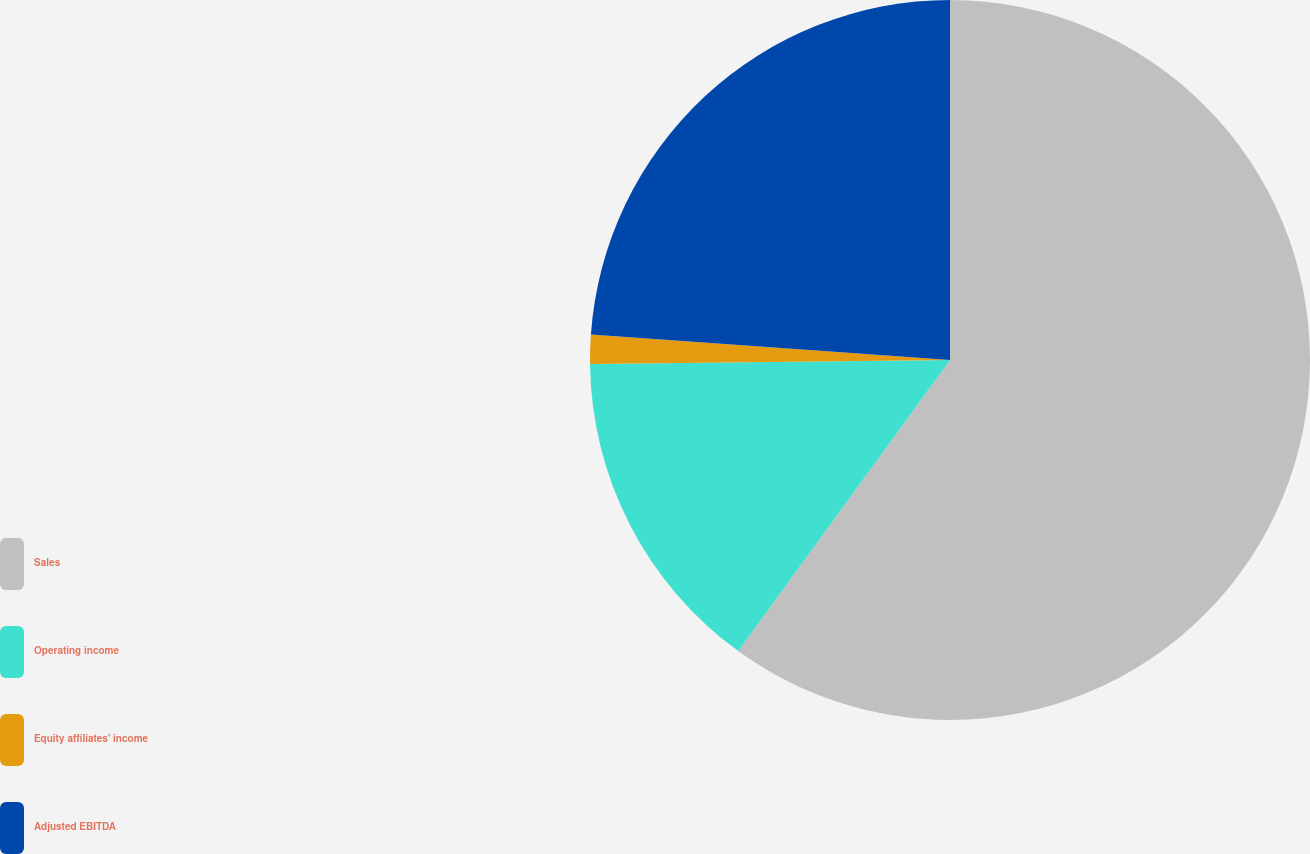Convert chart. <chart><loc_0><loc_0><loc_500><loc_500><pie_chart><fcel>Sales<fcel>Operating income<fcel>Equity affiliates' income<fcel>Adjusted EBITDA<nl><fcel>60.01%<fcel>14.81%<fcel>1.31%<fcel>23.87%<nl></chart> 